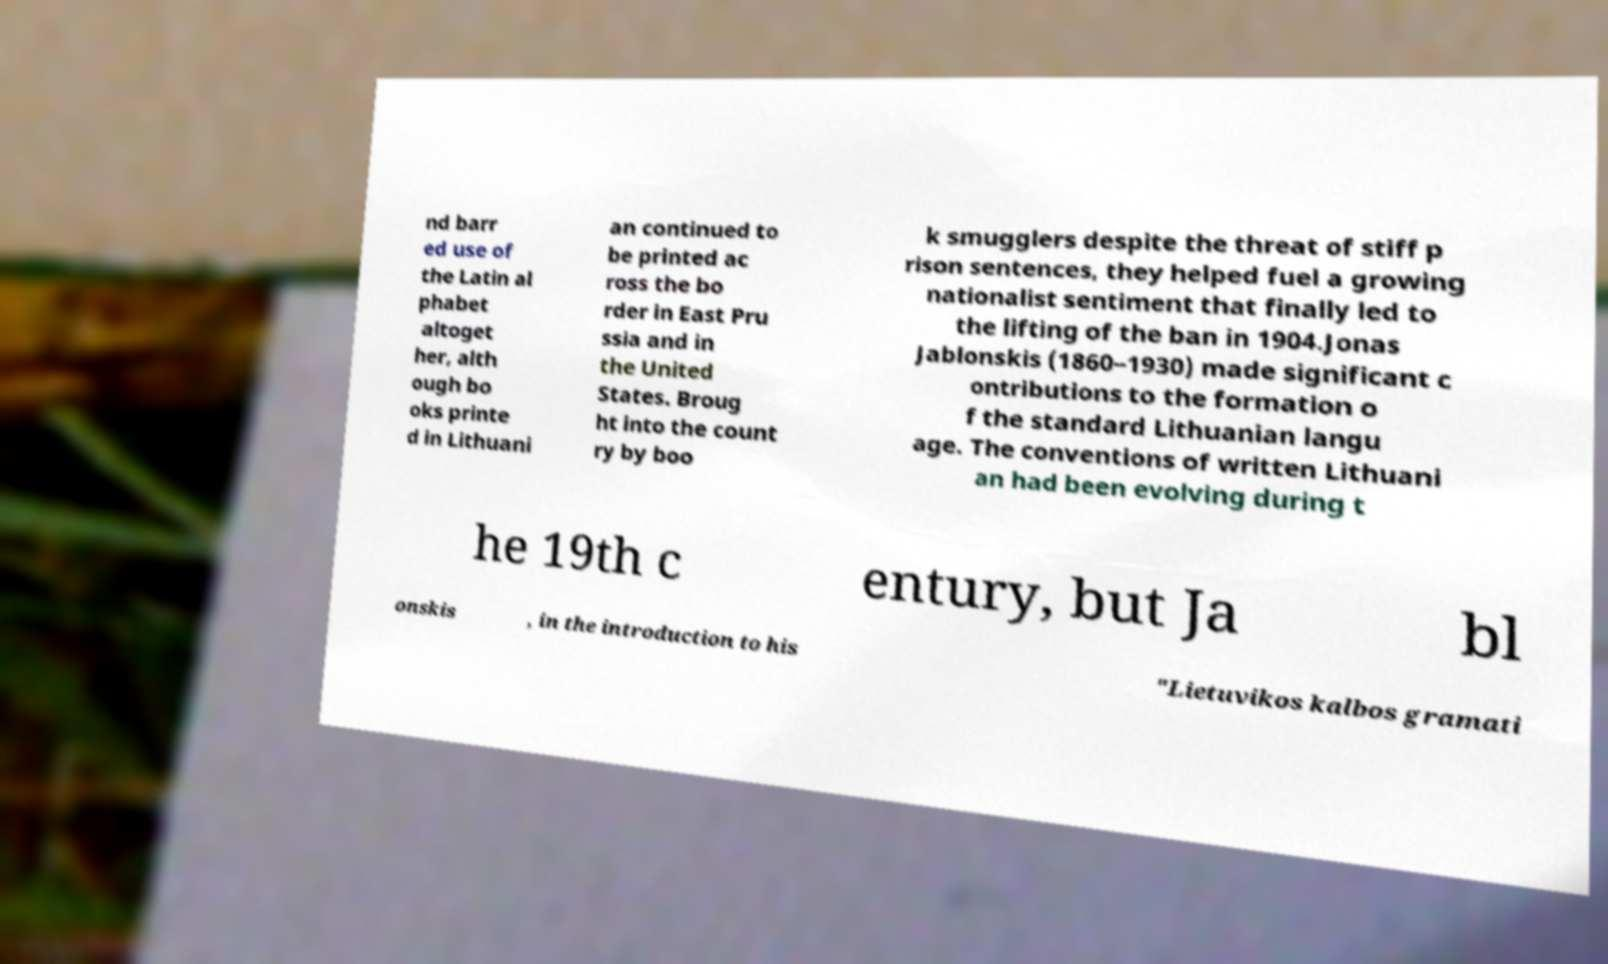What messages or text are displayed in this image? I need them in a readable, typed format. nd barr ed use of the Latin al phabet altoget her, alth ough bo oks printe d in Lithuani an continued to be printed ac ross the bo rder in East Pru ssia and in the United States. Broug ht into the count ry by boo k smugglers despite the threat of stiff p rison sentences, they helped fuel a growing nationalist sentiment that finally led to the lifting of the ban in 1904.Jonas Jablonskis (1860–1930) made significant c ontributions to the formation o f the standard Lithuanian langu age. The conventions of written Lithuani an had been evolving during t he 19th c entury, but Ja bl onskis , in the introduction to his "Lietuvikos kalbos gramati 